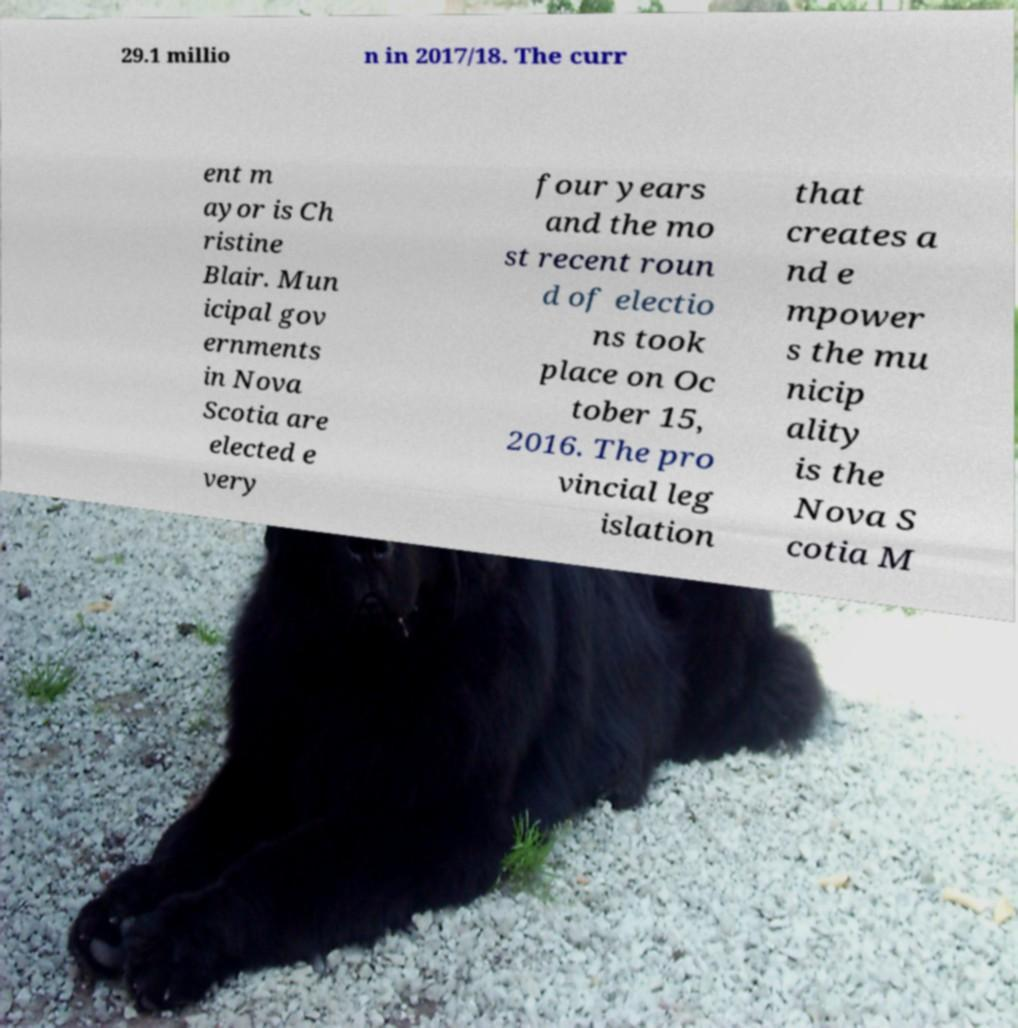Could you extract and type out the text from this image? 29.1 millio n in 2017/18. The curr ent m ayor is Ch ristine Blair. Mun icipal gov ernments in Nova Scotia are elected e very four years and the mo st recent roun d of electio ns took place on Oc tober 15, 2016. The pro vincial leg islation that creates a nd e mpower s the mu nicip ality is the Nova S cotia M 